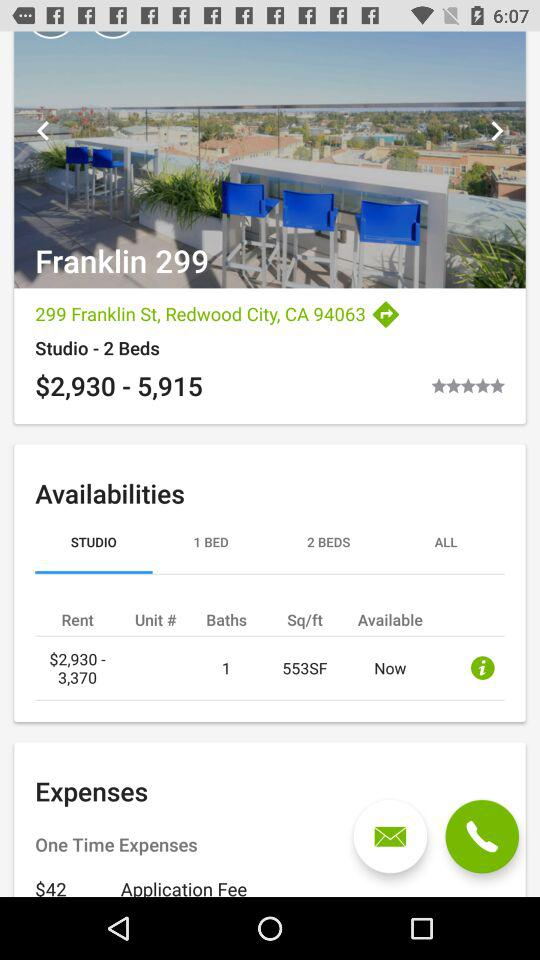What is the count of baths? The count of baths is 1. 